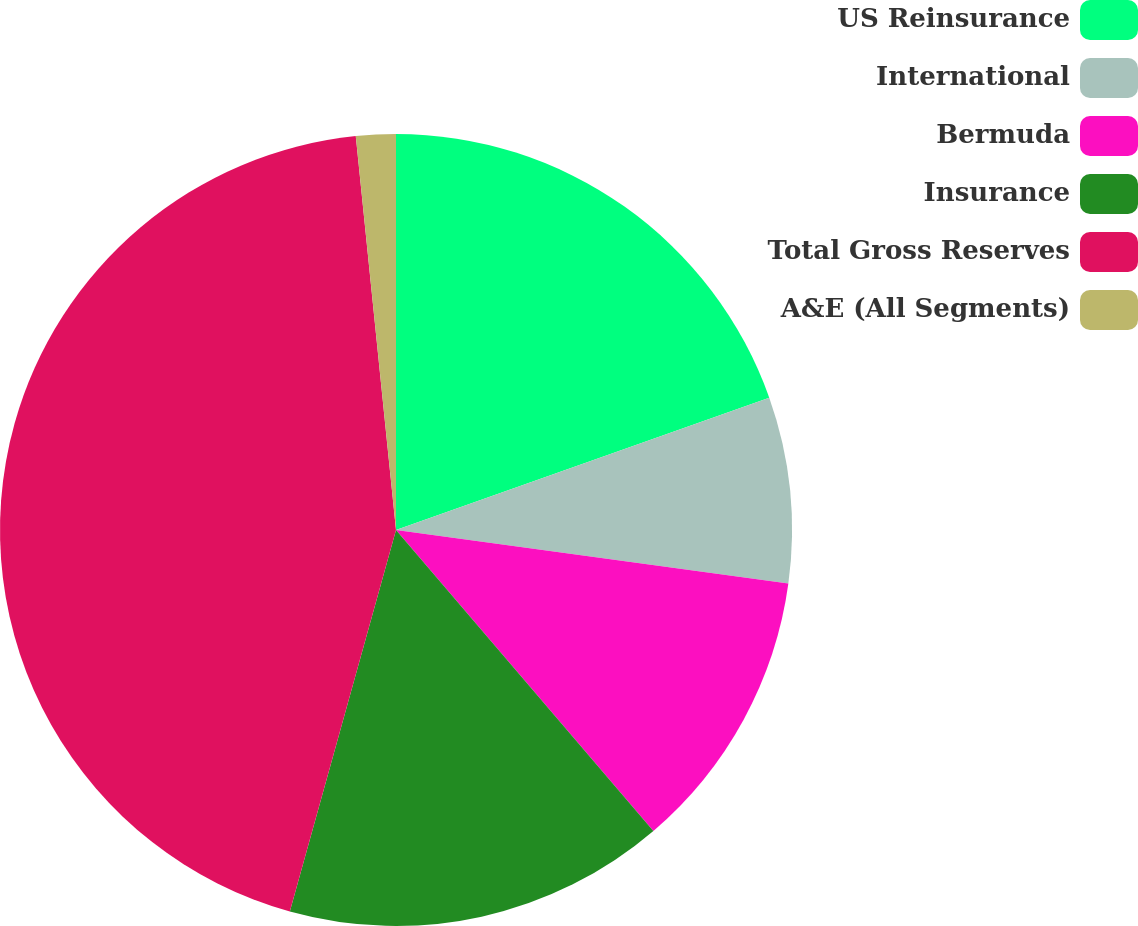Convert chart. <chart><loc_0><loc_0><loc_500><loc_500><pie_chart><fcel>US Reinsurance<fcel>International<fcel>Bermuda<fcel>Insurance<fcel>Total Gross Reserves<fcel>A&E (All Segments)<nl><fcel>19.58%<fcel>7.58%<fcel>11.58%<fcel>15.58%<fcel>44.06%<fcel>1.62%<nl></chart> 